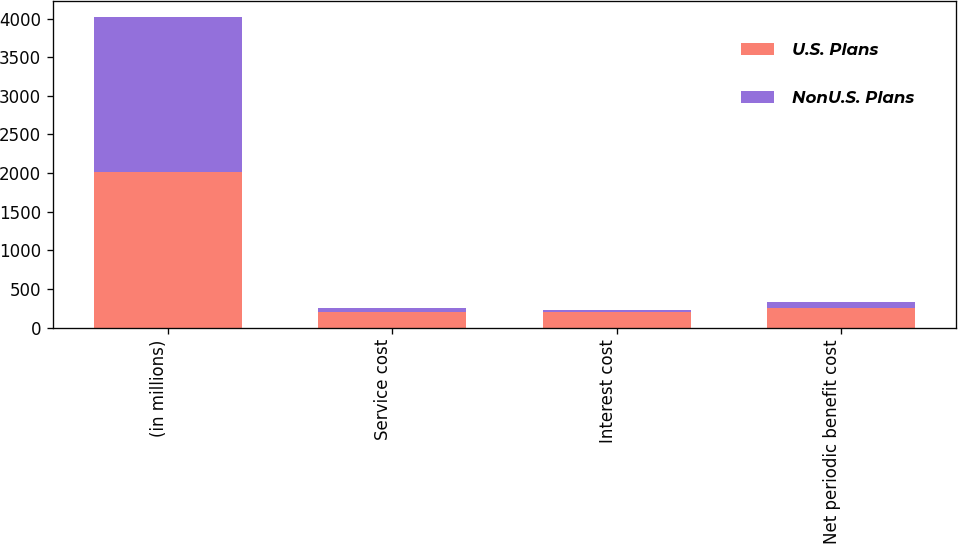Convert chart. <chart><loc_0><loc_0><loc_500><loc_500><stacked_bar_chart><ecel><fcel>(in millions)<fcel>Service cost<fcel>Interest cost<fcel>Net periodic benefit cost<nl><fcel>U.S. Plans<fcel>2013<fcel>205<fcel>201<fcel>254<nl><fcel>NonU.S. Plans<fcel>2013<fcel>47<fcel>29<fcel>72<nl></chart> 